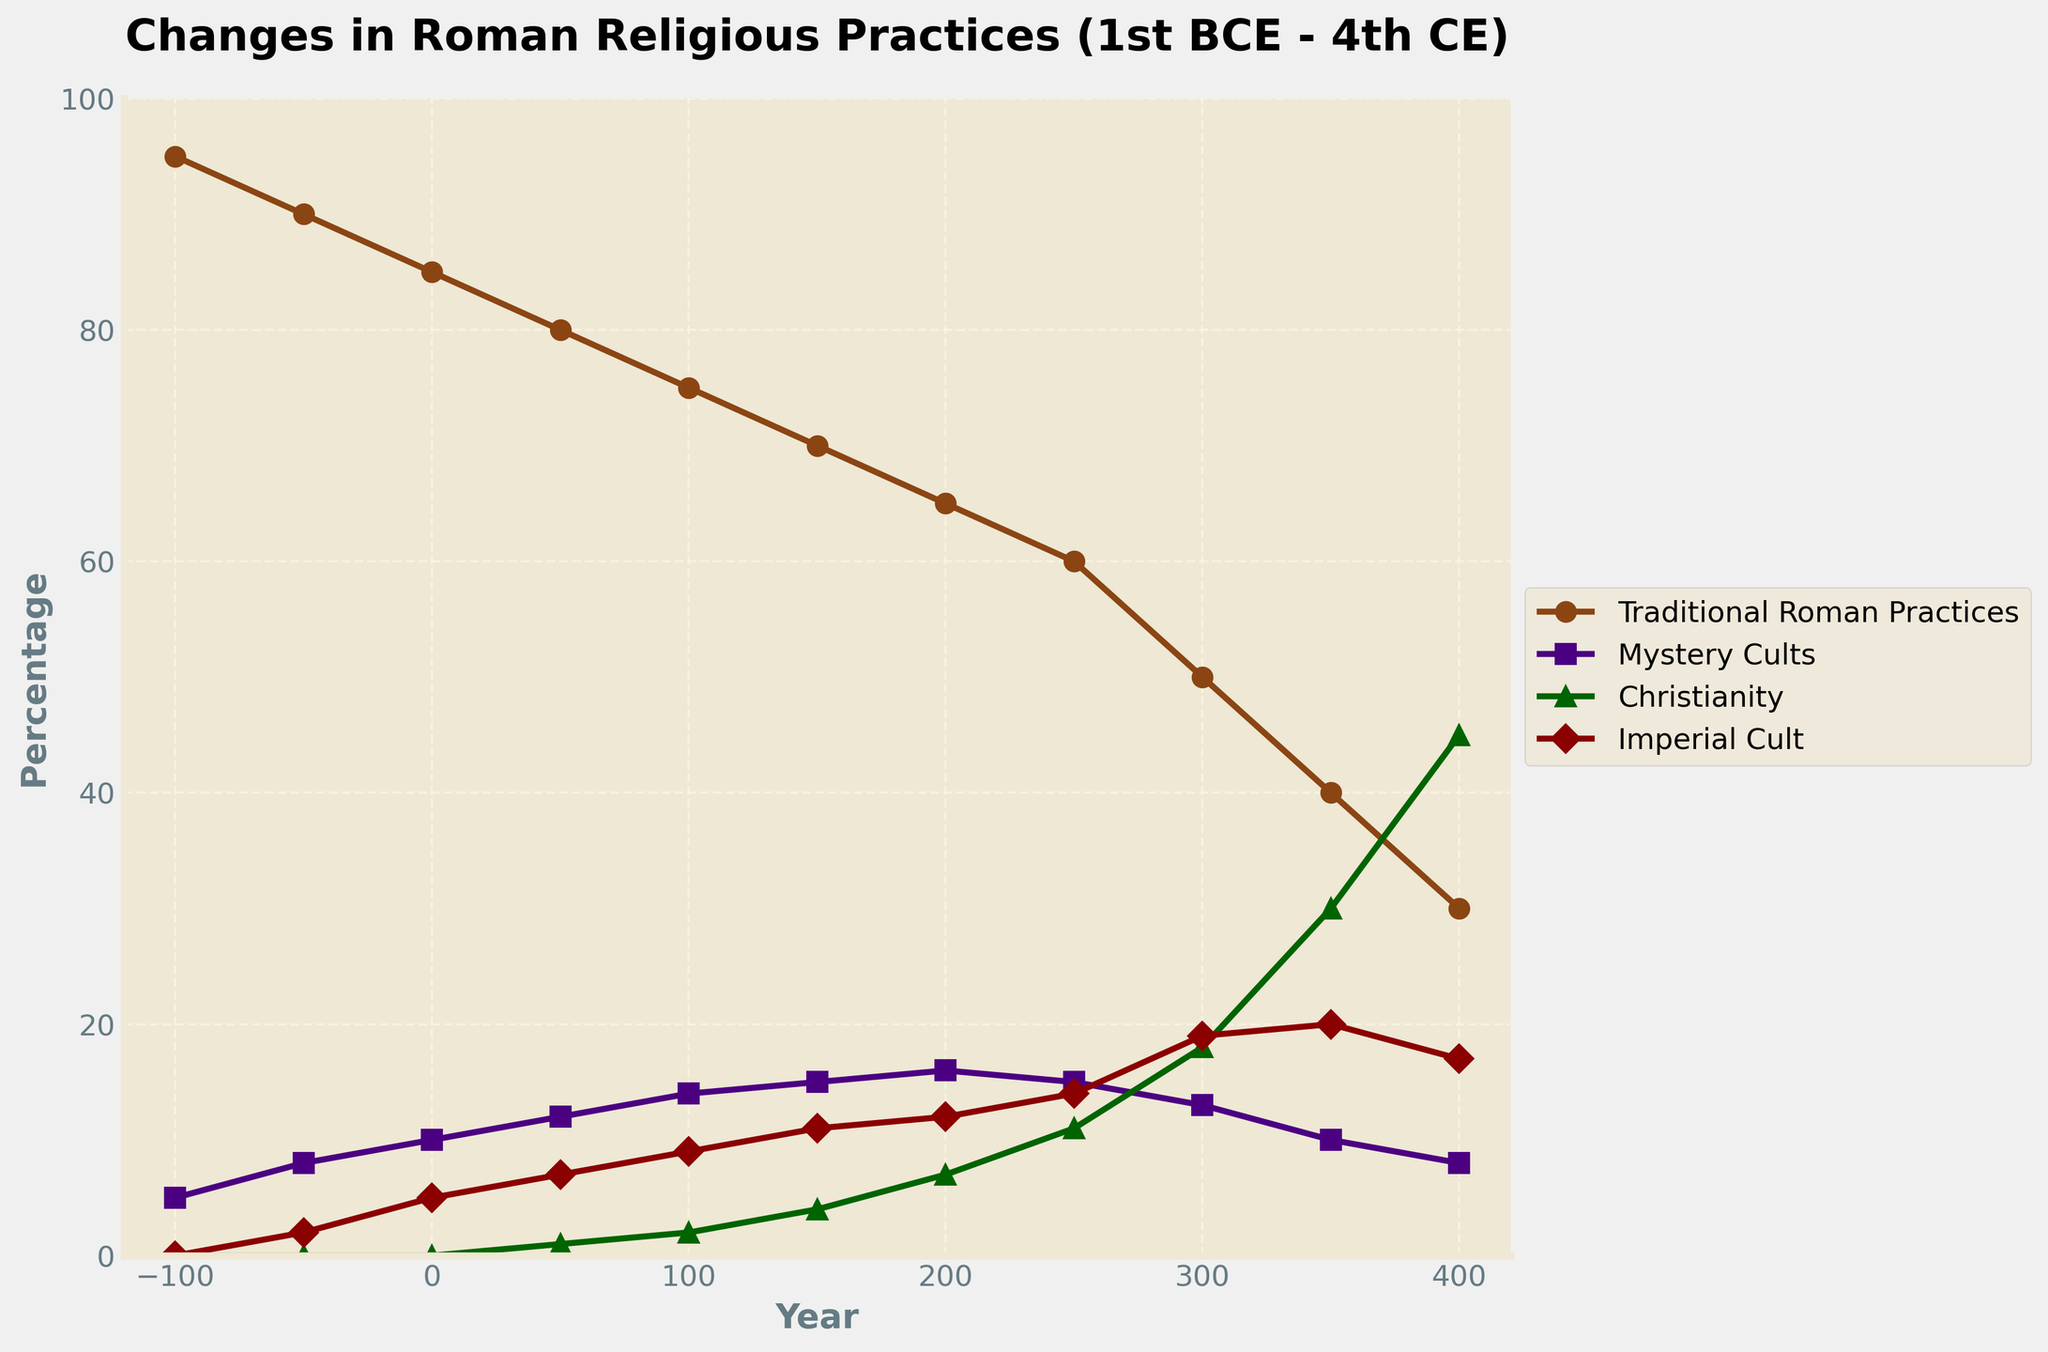what is the period during which Traditional Roman Practices saw the most significant decline? Observe the line representing Traditional Roman Practices. It shows the most noticeable decrease between 300 CE and 400 CE, dropping from 50% to 30% and showing the most significant change.
Answer: 300 CE to 400 CE which religious practice had the highest increase percentage during the period from 1st century CE to the 4th century CE? Look at the beginning and end points of each line. Christianity increased from 0% in the 1st century CE to 45% in the 4th century CE, which is the highest increase among all categories.
Answer: Christianity what was the dominant religious practice in 100 CE? Observe the data point at 100 CE for each practice. Traditional Roman Practices are around 75%, much higher than others.
Answer: Traditional Roman Practices which religious practice remained relatively stable throughout the entire period? Examine the slopes of the lines. Mystery Cults varied between 5% to 16%, showing less fluctuation compared to others.
Answer: Mystery Cults how did the presence of Christianity change from 0 to 100 CE versus from 300 to 400 CE? From 0 to 100 CE, Christianity increased from 0% to 2%. From 300 to 400 CE, it greatly increased from 18% to 45%. The latter period shows a much more substantial growth.
Answer: Greater increase from 300 to 400 CE in which year did Christianity surpass Traditional Roman Practices? Locate the intersection points of Christianity and Traditional Roman Practices. The intersection occurs between the 300 CE and 350 CE marks.
Answer: Between 300 and 350 CE how did the percentage of Mystery Cults compare to the Imperial Cult in 250 CE? Check the values at 250 CE for both Mystery Cults (15%) and the Imperial Cult (14%), showing that Mystery Cults were just slightly higher.
Answer: Mystery Cults were higher what is the average percentage of Traditional Roman Practices from 0 to 400 CE? Add the percentage values of Traditional Roman Practices at each given year (85, 80, 75, 70, 65, 60, 50, 40, 30) and divide by 9 to find the average. (85+80+75+70+65+60+50+40+30)/9 = 61.67
Answer: 61.67% during what period did the Imperial Cult show the most significant rise? Look at the steepness of the line representing the Imperial Cult. It is steepest between 0 CE and 100 CE, where it rises from 5% to 9%.
Answer: 0 CE to 100 CE 